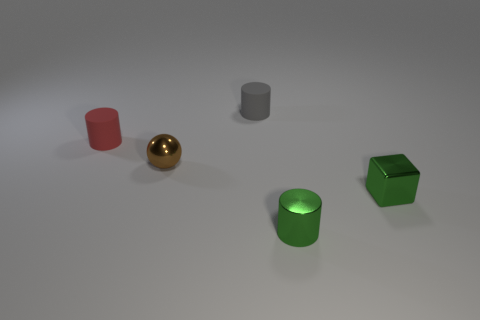Are there fewer small gray rubber cylinders that are behind the tiny red matte cylinder than red matte cylinders?
Give a very brief answer. No. What material is the small cylinder in front of the rubber thing that is left of the brown ball?
Provide a short and direct response. Metal. There is a small shiny thing that is behind the small metallic cylinder and on the right side of the tiny brown metallic object; what is its shape?
Ensure brevity in your answer.  Cube. What number of other things are there of the same color as the cube?
Keep it short and to the point. 1. How many things are either metallic objects that are right of the shiny ball or tiny yellow cubes?
Make the answer very short. 2. There is a cube; is it the same color as the cylinder in front of the tiny green metal cube?
Offer a very short reply. Yes. What number of objects are either brown things or tiny cylinders that are in front of the tiny gray rubber cylinder?
Provide a succinct answer. 3. There is a matte thing to the right of the tiny brown sphere; is its shape the same as the small red rubber thing?
Provide a succinct answer. Yes. There is a metal object in front of the green object that is to the right of the tiny metal cylinder; what number of cylinders are on the left side of it?
Provide a short and direct response. 2. Are there any other things that are the same shape as the tiny brown object?
Give a very brief answer. No. 